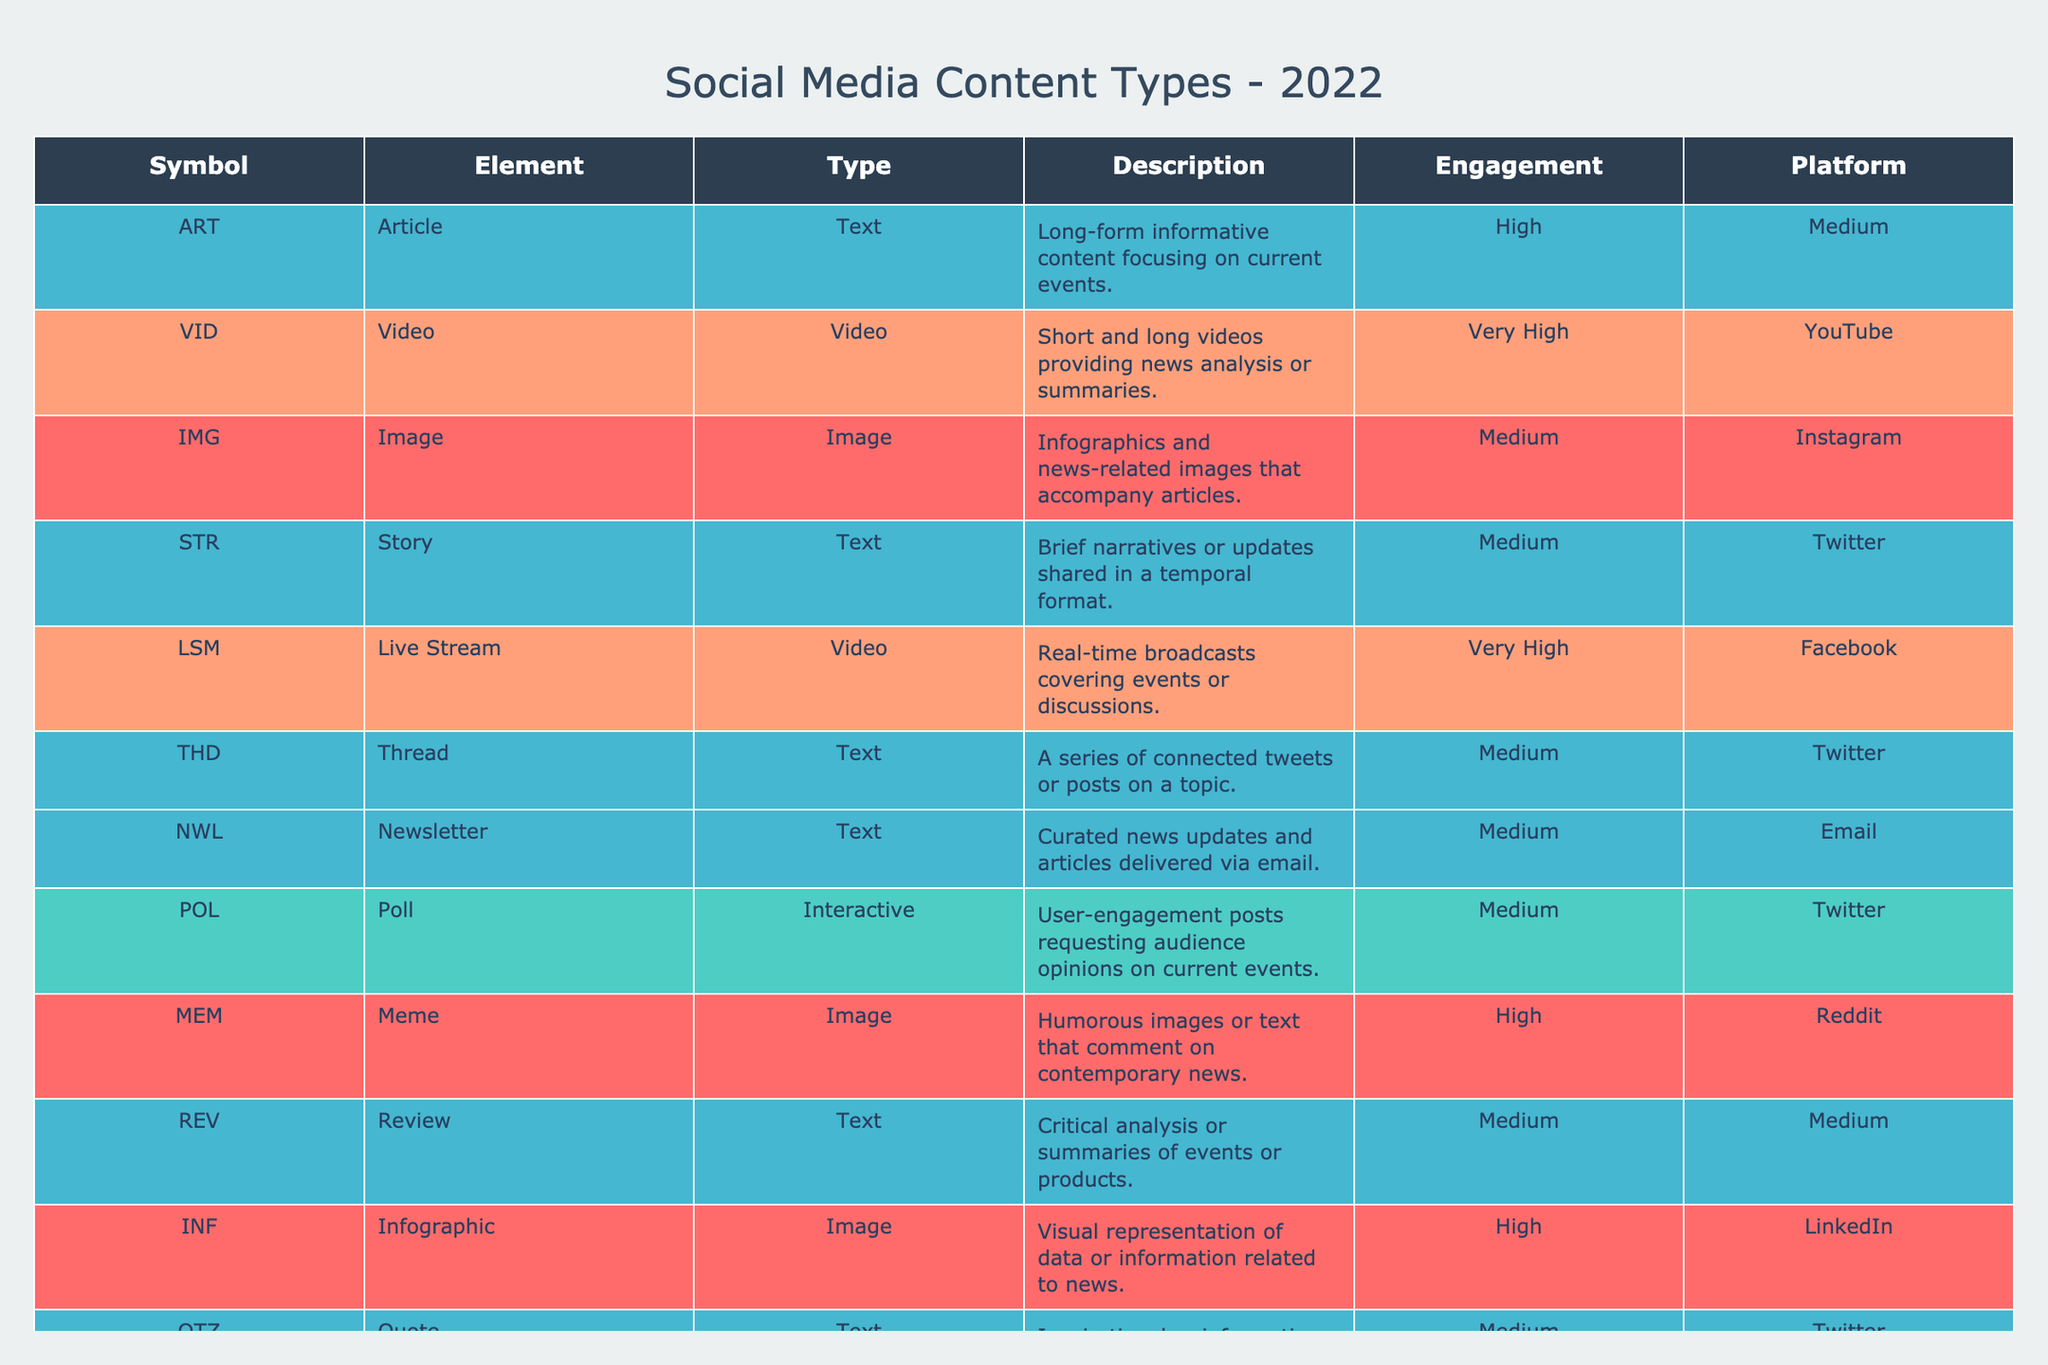What type of content has the highest engagement level? According to the table, the content types "Video" and "Live Stream" both have a "Very High" engagement level.
Answer: Video and Live Stream Which platform is associated with the least engagement level content type? The table shows that "Newsletter" and "Thread" have a "Medium" engagement level, but there are no low engagement types mentioned, so it can be inferred that they might be the least engaging overall.
Answer: Newsletter and Thread How many types of interactive content are listed? The table lists one interactive type, which is "Poll." Therefore, the count is one.
Answer: 1 Is the engagement level for "Image" content type higher than "Article"? The engagement level for "Image" is "Medium," while "Article" is "High." Since “Medium” is not higher than “High,” the answer is no.
Answer: No What is the average engagement level of the content types listed on Twitter? The content types shared on Twitter are "Story," "Thread," and "Poll," each rated as "Medium." To find the average, count the number of entries (3) and determine the engagement level is "Medium." Therefore, it stays at "Medium."
Answer: Medium Which platform has the most varied engagement levels in the table? "Twitter" has three types of content ("Story," "Thread," "Poll") with the same engagement level, which is "Medium." Other platforms have more distinct engagement levels such as "Very High" or "High." Thus, it is determined that Twitter has a consistent engagement level but may not vary.
Answer: Twitter Can "Infographic" be considered a more engaging type of content compared to "Meme"? Both "Infographic" and "Meme" have a "High" engagement level; thus, neither can be seen as more engaging than the other since they are equal in that aspect.
Answer: No Which content type is solely focused on visual representation? The "Infographic" content type and "Data Visualization" are both focused solely on visual representation. However, if we consider only one, "Infographic" is more commonly associated with such classification.
Answer: Infographic What is the total number of text-based content types? The table lists four text-based types: "Article," "Story," "Thread," and "Quote." Thus, summing them gives a total of four text types.
Answer: 4 